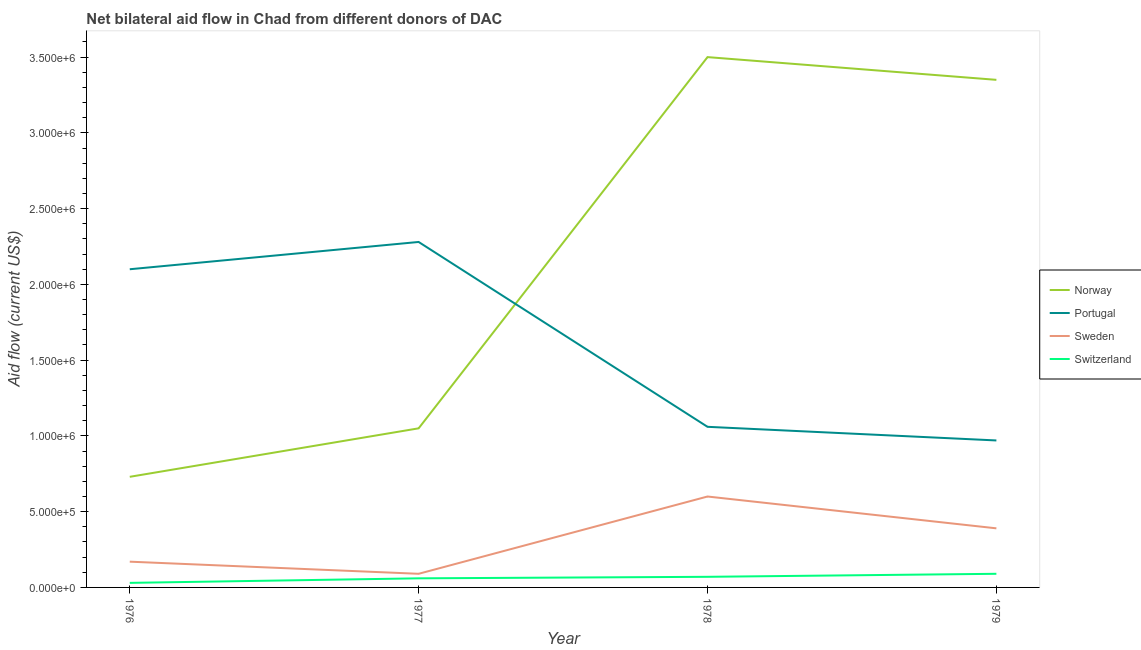Is the number of lines equal to the number of legend labels?
Offer a terse response. Yes. What is the amount of aid given by sweden in 1978?
Your answer should be compact. 6.00e+05. Across all years, what is the maximum amount of aid given by switzerland?
Your answer should be compact. 9.00e+04. Across all years, what is the minimum amount of aid given by sweden?
Give a very brief answer. 9.00e+04. In which year was the amount of aid given by portugal minimum?
Offer a very short reply. 1979. What is the total amount of aid given by switzerland in the graph?
Offer a terse response. 2.50e+05. What is the difference between the amount of aid given by sweden in 1976 and that in 1977?
Offer a terse response. 8.00e+04. What is the difference between the amount of aid given by portugal in 1979 and the amount of aid given by sweden in 1976?
Keep it short and to the point. 8.00e+05. What is the average amount of aid given by portugal per year?
Give a very brief answer. 1.60e+06. In the year 1976, what is the difference between the amount of aid given by portugal and amount of aid given by norway?
Provide a short and direct response. 1.37e+06. What is the ratio of the amount of aid given by switzerland in 1977 to that in 1979?
Make the answer very short. 0.67. What is the difference between the highest and the second highest amount of aid given by portugal?
Offer a very short reply. 1.80e+05. What is the difference between the highest and the lowest amount of aid given by switzerland?
Give a very brief answer. 6.00e+04. Is it the case that in every year, the sum of the amount of aid given by norway and amount of aid given by switzerland is greater than the sum of amount of aid given by sweden and amount of aid given by portugal?
Provide a short and direct response. No. Does the amount of aid given by switzerland monotonically increase over the years?
Provide a short and direct response. Yes. Is the amount of aid given by switzerland strictly greater than the amount of aid given by portugal over the years?
Ensure brevity in your answer.  No. Is the amount of aid given by sweden strictly less than the amount of aid given by switzerland over the years?
Ensure brevity in your answer.  No. How many years are there in the graph?
Your answer should be very brief. 4. Are the values on the major ticks of Y-axis written in scientific E-notation?
Make the answer very short. Yes. Does the graph contain grids?
Give a very brief answer. No. Where does the legend appear in the graph?
Provide a short and direct response. Center right. How many legend labels are there?
Provide a short and direct response. 4. How are the legend labels stacked?
Give a very brief answer. Vertical. What is the title of the graph?
Your answer should be very brief. Net bilateral aid flow in Chad from different donors of DAC. What is the label or title of the X-axis?
Your answer should be compact. Year. What is the Aid flow (current US$) in Norway in 1976?
Offer a terse response. 7.30e+05. What is the Aid flow (current US$) of Portugal in 1976?
Give a very brief answer. 2.10e+06. What is the Aid flow (current US$) in Norway in 1977?
Offer a very short reply. 1.05e+06. What is the Aid flow (current US$) of Portugal in 1977?
Ensure brevity in your answer.  2.28e+06. What is the Aid flow (current US$) of Sweden in 1977?
Give a very brief answer. 9.00e+04. What is the Aid flow (current US$) in Norway in 1978?
Offer a terse response. 3.50e+06. What is the Aid flow (current US$) of Portugal in 1978?
Your answer should be compact. 1.06e+06. What is the Aid flow (current US$) of Norway in 1979?
Your answer should be compact. 3.35e+06. What is the Aid flow (current US$) of Portugal in 1979?
Ensure brevity in your answer.  9.70e+05. What is the Aid flow (current US$) in Sweden in 1979?
Your answer should be compact. 3.90e+05. What is the Aid flow (current US$) in Switzerland in 1979?
Your answer should be very brief. 9.00e+04. Across all years, what is the maximum Aid flow (current US$) in Norway?
Your response must be concise. 3.50e+06. Across all years, what is the maximum Aid flow (current US$) of Portugal?
Ensure brevity in your answer.  2.28e+06. Across all years, what is the maximum Aid flow (current US$) in Sweden?
Make the answer very short. 6.00e+05. Across all years, what is the maximum Aid flow (current US$) of Switzerland?
Provide a succinct answer. 9.00e+04. Across all years, what is the minimum Aid flow (current US$) of Norway?
Your answer should be very brief. 7.30e+05. Across all years, what is the minimum Aid flow (current US$) of Portugal?
Make the answer very short. 9.70e+05. What is the total Aid flow (current US$) in Norway in the graph?
Your answer should be very brief. 8.63e+06. What is the total Aid flow (current US$) in Portugal in the graph?
Your answer should be compact. 6.41e+06. What is the total Aid flow (current US$) of Sweden in the graph?
Your answer should be compact. 1.25e+06. What is the total Aid flow (current US$) in Switzerland in the graph?
Offer a terse response. 2.50e+05. What is the difference between the Aid flow (current US$) in Norway in 1976 and that in 1977?
Provide a succinct answer. -3.20e+05. What is the difference between the Aid flow (current US$) in Portugal in 1976 and that in 1977?
Ensure brevity in your answer.  -1.80e+05. What is the difference between the Aid flow (current US$) in Sweden in 1976 and that in 1977?
Provide a succinct answer. 8.00e+04. What is the difference between the Aid flow (current US$) of Norway in 1976 and that in 1978?
Your answer should be very brief. -2.77e+06. What is the difference between the Aid flow (current US$) in Portugal in 1976 and that in 1978?
Ensure brevity in your answer.  1.04e+06. What is the difference between the Aid flow (current US$) of Sweden in 1976 and that in 1978?
Your answer should be compact. -4.30e+05. What is the difference between the Aid flow (current US$) in Switzerland in 1976 and that in 1978?
Keep it short and to the point. -4.00e+04. What is the difference between the Aid flow (current US$) in Norway in 1976 and that in 1979?
Provide a succinct answer. -2.62e+06. What is the difference between the Aid flow (current US$) in Portugal in 1976 and that in 1979?
Your response must be concise. 1.13e+06. What is the difference between the Aid flow (current US$) of Sweden in 1976 and that in 1979?
Keep it short and to the point. -2.20e+05. What is the difference between the Aid flow (current US$) in Norway in 1977 and that in 1978?
Your answer should be compact. -2.45e+06. What is the difference between the Aid flow (current US$) of Portugal in 1977 and that in 1978?
Provide a succinct answer. 1.22e+06. What is the difference between the Aid flow (current US$) in Sweden in 1977 and that in 1978?
Keep it short and to the point. -5.10e+05. What is the difference between the Aid flow (current US$) of Switzerland in 1977 and that in 1978?
Offer a terse response. -10000. What is the difference between the Aid flow (current US$) in Norway in 1977 and that in 1979?
Your response must be concise. -2.30e+06. What is the difference between the Aid flow (current US$) of Portugal in 1977 and that in 1979?
Your answer should be very brief. 1.31e+06. What is the difference between the Aid flow (current US$) in Switzerland in 1977 and that in 1979?
Offer a terse response. -3.00e+04. What is the difference between the Aid flow (current US$) in Norway in 1978 and that in 1979?
Give a very brief answer. 1.50e+05. What is the difference between the Aid flow (current US$) in Sweden in 1978 and that in 1979?
Your response must be concise. 2.10e+05. What is the difference between the Aid flow (current US$) of Norway in 1976 and the Aid flow (current US$) of Portugal in 1977?
Give a very brief answer. -1.55e+06. What is the difference between the Aid flow (current US$) of Norway in 1976 and the Aid flow (current US$) of Sweden in 1977?
Your answer should be compact. 6.40e+05. What is the difference between the Aid flow (current US$) in Norway in 1976 and the Aid flow (current US$) in Switzerland in 1977?
Your answer should be very brief. 6.70e+05. What is the difference between the Aid flow (current US$) in Portugal in 1976 and the Aid flow (current US$) in Sweden in 1977?
Offer a very short reply. 2.01e+06. What is the difference between the Aid flow (current US$) of Portugal in 1976 and the Aid flow (current US$) of Switzerland in 1977?
Ensure brevity in your answer.  2.04e+06. What is the difference between the Aid flow (current US$) of Sweden in 1976 and the Aid flow (current US$) of Switzerland in 1977?
Ensure brevity in your answer.  1.10e+05. What is the difference between the Aid flow (current US$) of Norway in 1976 and the Aid flow (current US$) of Portugal in 1978?
Offer a very short reply. -3.30e+05. What is the difference between the Aid flow (current US$) in Portugal in 1976 and the Aid flow (current US$) in Sweden in 1978?
Give a very brief answer. 1.50e+06. What is the difference between the Aid flow (current US$) of Portugal in 1976 and the Aid flow (current US$) of Switzerland in 1978?
Your answer should be very brief. 2.03e+06. What is the difference between the Aid flow (current US$) of Norway in 1976 and the Aid flow (current US$) of Switzerland in 1979?
Offer a very short reply. 6.40e+05. What is the difference between the Aid flow (current US$) of Portugal in 1976 and the Aid flow (current US$) of Sweden in 1979?
Your answer should be very brief. 1.71e+06. What is the difference between the Aid flow (current US$) in Portugal in 1976 and the Aid flow (current US$) in Switzerland in 1979?
Provide a succinct answer. 2.01e+06. What is the difference between the Aid flow (current US$) in Sweden in 1976 and the Aid flow (current US$) in Switzerland in 1979?
Your answer should be very brief. 8.00e+04. What is the difference between the Aid flow (current US$) in Norway in 1977 and the Aid flow (current US$) in Switzerland in 1978?
Keep it short and to the point. 9.80e+05. What is the difference between the Aid flow (current US$) of Portugal in 1977 and the Aid flow (current US$) of Sweden in 1978?
Offer a very short reply. 1.68e+06. What is the difference between the Aid flow (current US$) of Portugal in 1977 and the Aid flow (current US$) of Switzerland in 1978?
Your response must be concise. 2.21e+06. What is the difference between the Aid flow (current US$) of Sweden in 1977 and the Aid flow (current US$) of Switzerland in 1978?
Keep it short and to the point. 2.00e+04. What is the difference between the Aid flow (current US$) of Norway in 1977 and the Aid flow (current US$) of Sweden in 1979?
Ensure brevity in your answer.  6.60e+05. What is the difference between the Aid flow (current US$) in Norway in 1977 and the Aid flow (current US$) in Switzerland in 1979?
Make the answer very short. 9.60e+05. What is the difference between the Aid flow (current US$) in Portugal in 1977 and the Aid flow (current US$) in Sweden in 1979?
Provide a succinct answer. 1.89e+06. What is the difference between the Aid flow (current US$) of Portugal in 1977 and the Aid flow (current US$) of Switzerland in 1979?
Give a very brief answer. 2.19e+06. What is the difference between the Aid flow (current US$) of Norway in 1978 and the Aid flow (current US$) of Portugal in 1979?
Your answer should be compact. 2.53e+06. What is the difference between the Aid flow (current US$) of Norway in 1978 and the Aid flow (current US$) of Sweden in 1979?
Offer a terse response. 3.11e+06. What is the difference between the Aid flow (current US$) in Norway in 1978 and the Aid flow (current US$) in Switzerland in 1979?
Provide a short and direct response. 3.41e+06. What is the difference between the Aid flow (current US$) of Portugal in 1978 and the Aid flow (current US$) of Sweden in 1979?
Your response must be concise. 6.70e+05. What is the difference between the Aid flow (current US$) of Portugal in 1978 and the Aid flow (current US$) of Switzerland in 1979?
Make the answer very short. 9.70e+05. What is the difference between the Aid flow (current US$) in Sweden in 1978 and the Aid flow (current US$) in Switzerland in 1979?
Provide a short and direct response. 5.10e+05. What is the average Aid flow (current US$) in Norway per year?
Provide a short and direct response. 2.16e+06. What is the average Aid flow (current US$) of Portugal per year?
Your response must be concise. 1.60e+06. What is the average Aid flow (current US$) of Sweden per year?
Give a very brief answer. 3.12e+05. What is the average Aid flow (current US$) in Switzerland per year?
Offer a very short reply. 6.25e+04. In the year 1976, what is the difference between the Aid flow (current US$) of Norway and Aid flow (current US$) of Portugal?
Offer a terse response. -1.37e+06. In the year 1976, what is the difference between the Aid flow (current US$) of Norway and Aid flow (current US$) of Sweden?
Offer a terse response. 5.60e+05. In the year 1976, what is the difference between the Aid flow (current US$) in Norway and Aid flow (current US$) in Switzerland?
Keep it short and to the point. 7.00e+05. In the year 1976, what is the difference between the Aid flow (current US$) in Portugal and Aid flow (current US$) in Sweden?
Offer a very short reply. 1.93e+06. In the year 1976, what is the difference between the Aid flow (current US$) of Portugal and Aid flow (current US$) of Switzerland?
Provide a short and direct response. 2.07e+06. In the year 1976, what is the difference between the Aid flow (current US$) of Sweden and Aid flow (current US$) of Switzerland?
Provide a short and direct response. 1.40e+05. In the year 1977, what is the difference between the Aid flow (current US$) in Norway and Aid flow (current US$) in Portugal?
Offer a terse response. -1.23e+06. In the year 1977, what is the difference between the Aid flow (current US$) of Norway and Aid flow (current US$) of Sweden?
Provide a succinct answer. 9.60e+05. In the year 1977, what is the difference between the Aid flow (current US$) in Norway and Aid flow (current US$) in Switzerland?
Keep it short and to the point. 9.90e+05. In the year 1977, what is the difference between the Aid flow (current US$) in Portugal and Aid flow (current US$) in Sweden?
Keep it short and to the point. 2.19e+06. In the year 1977, what is the difference between the Aid flow (current US$) in Portugal and Aid flow (current US$) in Switzerland?
Offer a terse response. 2.22e+06. In the year 1978, what is the difference between the Aid flow (current US$) in Norway and Aid flow (current US$) in Portugal?
Your answer should be compact. 2.44e+06. In the year 1978, what is the difference between the Aid flow (current US$) in Norway and Aid flow (current US$) in Sweden?
Offer a terse response. 2.90e+06. In the year 1978, what is the difference between the Aid flow (current US$) in Norway and Aid flow (current US$) in Switzerland?
Your answer should be very brief. 3.43e+06. In the year 1978, what is the difference between the Aid flow (current US$) of Portugal and Aid flow (current US$) of Sweden?
Make the answer very short. 4.60e+05. In the year 1978, what is the difference between the Aid flow (current US$) in Portugal and Aid flow (current US$) in Switzerland?
Ensure brevity in your answer.  9.90e+05. In the year 1978, what is the difference between the Aid flow (current US$) of Sweden and Aid flow (current US$) of Switzerland?
Offer a terse response. 5.30e+05. In the year 1979, what is the difference between the Aid flow (current US$) in Norway and Aid flow (current US$) in Portugal?
Ensure brevity in your answer.  2.38e+06. In the year 1979, what is the difference between the Aid flow (current US$) in Norway and Aid flow (current US$) in Sweden?
Make the answer very short. 2.96e+06. In the year 1979, what is the difference between the Aid flow (current US$) of Norway and Aid flow (current US$) of Switzerland?
Provide a short and direct response. 3.26e+06. In the year 1979, what is the difference between the Aid flow (current US$) of Portugal and Aid flow (current US$) of Sweden?
Your answer should be very brief. 5.80e+05. In the year 1979, what is the difference between the Aid flow (current US$) of Portugal and Aid flow (current US$) of Switzerland?
Make the answer very short. 8.80e+05. In the year 1979, what is the difference between the Aid flow (current US$) of Sweden and Aid flow (current US$) of Switzerland?
Make the answer very short. 3.00e+05. What is the ratio of the Aid flow (current US$) in Norway in 1976 to that in 1977?
Provide a short and direct response. 0.7. What is the ratio of the Aid flow (current US$) of Portugal in 1976 to that in 1977?
Keep it short and to the point. 0.92. What is the ratio of the Aid flow (current US$) in Sweden in 1976 to that in 1977?
Provide a short and direct response. 1.89. What is the ratio of the Aid flow (current US$) in Norway in 1976 to that in 1978?
Offer a terse response. 0.21. What is the ratio of the Aid flow (current US$) of Portugal in 1976 to that in 1978?
Your answer should be compact. 1.98. What is the ratio of the Aid flow (current US$) in Sweden in 1976 to that in 1978?
Your answer should be compact. 0.28. What is the ratio of the Aid flow (current US$) in Switzerland in 1976 to that in 1978?
Your response must be concise. 0.43. What is the ratio of the Aid flow (current US$) of Norway in 1976 to that in 1979?
Provide a short and direct response. 0.22. What is the ratio of the Aid flow (current US$) of Portugal in 1976 to that in 1979?
Offer a terse response. 2.16. What is the ratio of the Aid flow (current US$) in Sweden in 1976 to that in 1979?
Offer a terse response. 0.44. What is the ratio of the Aid flow (current US$) in Portugal in 1977 to that in 1978?
Provide a succinct answer. 2.15. What is the ratio of the Aid flow (current US$) of Sweden in 1977 to that in 1978?
Offer a terse response. 0.15. What is the ratio of the Aid flow (current US$) in Norway in 1977 to that in 1979?
Your answer should be very brief. 0.31. What is the ratio of the Aid flow (current US$) in Portugal in 1977 to that in 1979?
Provide a succinct answer. 2.35. What is the ratio of the Aid flow (current US$) of Sweden in 1977 to that in 1979?
Offer a terse response. 0.23. What is the ratio of the Aid flow (current US$) in Norway in 1978 to that in 1979?
Your answer should be very brief. 1.04. What is the ratio of the Aid flow (current US$) of Portugal in 1978 to that in 1979?
Offer a very short reply. 1.09. What is the ratio of the Aid flow (current US$) of Sweden in 1978 to that in 1979?
Make the answer very short. 1.54. What is the difference between the highest and the second highest Aid flow (current US$) in Norway?
Offer a very short reply. 1.50e+05. What is the difference between the highest and the second highest Aid flow (current US$) of Portugal?
Provide a succinct answer. 1.80e+05. What is the difference between the highest and the second highest Aid flow (current US$) in Sweden?
Your answer should be compact. 2.10e+05. What is the difference between the highest and the lowest Aid flow (current US$) of Norway?
Make the answer very short. 2.77e+06. What is the difference between the highest and the lowest Aid flow (current US$) in Portugal?
Your answer should be very brief. 1.31e+06. What is the difference between the highest and the lowest Aid flow (current US$) in Sweden?
Offer a very short reply. 5.10e+05. What is the difference between the highest and the lowest Aid flow (current US$) of Switzerland?
Your answer should be very brief. 6.00e+04. 